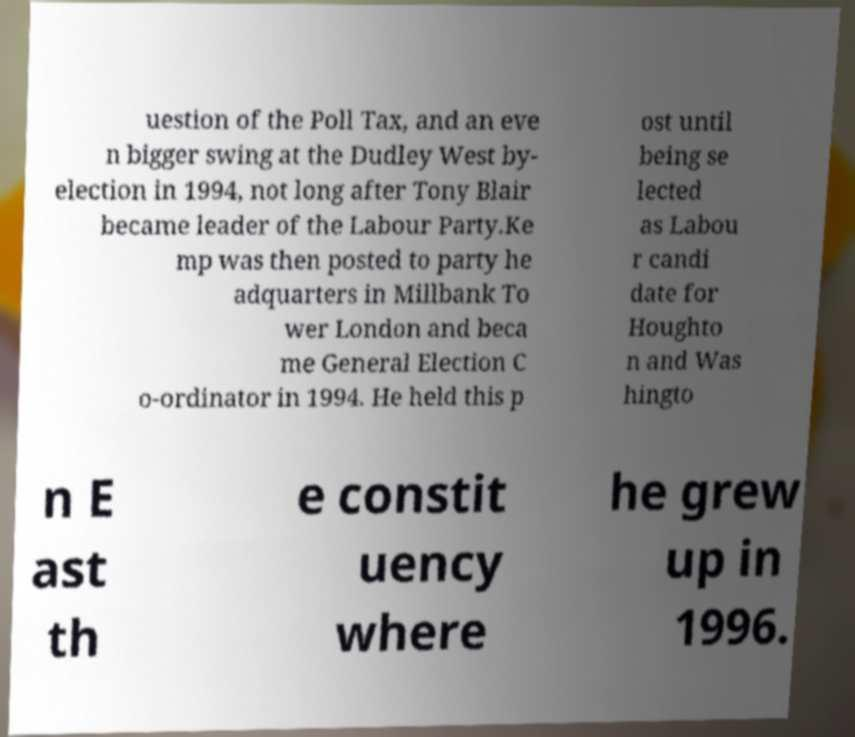Can you read and provide the text displayed in the image?This photo seems to have some interesting text. Can you extract and type it out for me? uestion of the Poll Tax, and an eve n bigger swing at the Dudley West by- election in 1994, not long after Tony Blair became leader of the Labour Party.Ke mp was then posted to party he adquarters in Millbank To wer London and beca me General Election C o-ordinator in 1994. He held this p ost until being se lected as Labou r candi date for Houghto n and Was hingto n E ast th e constit uency where he grew up in 1996. 